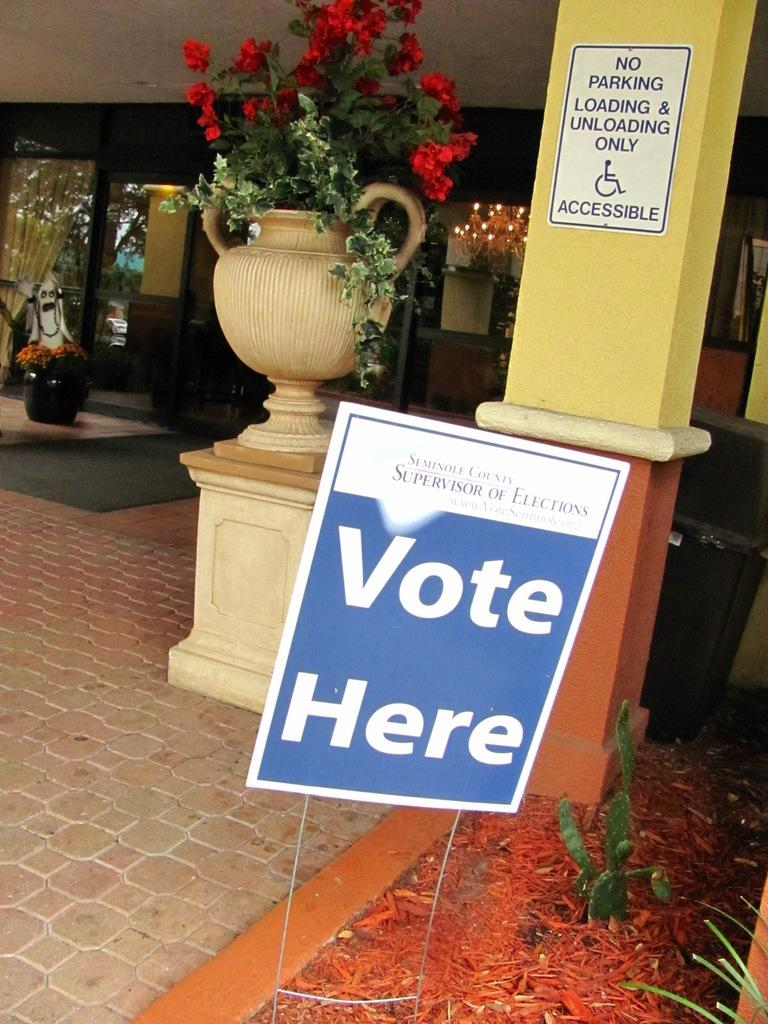What type of objects can be seen in the image? There are flower pots, lights, poles, and posters in the image. Can you describe the plant in the image? There is a plant in the bottom right corner of the image. What might the poles be used for in the image? The poles might be used to support the lights or posters in the image. What type of shoe can be seen hanging from the pole in the image? There is no shoe hanging from the pole in the image; only flower pots, lights, poles, and posters are present. 